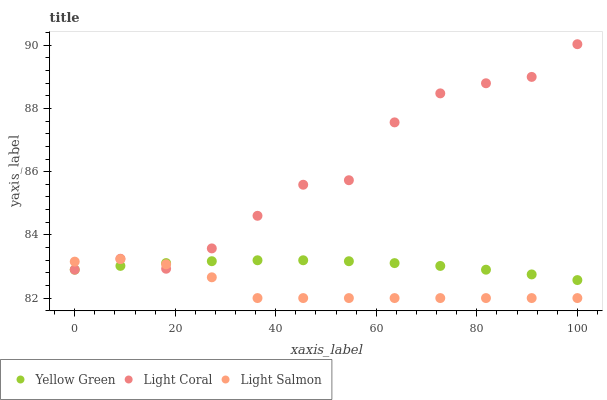Does Light Salmon have the minimum area under the curve?
Answer yes or no. Yes. Does Light Coral have the maximum area under the curve?
Answer yes or no. Yes. Does Yellow Green have the minimum area under the curve?
Answer yes or no. No. Does Yellow Green have the maximum area under the curve?
Answer yes or no. No. Is Yellow Green the smoothest?
Answer yes or no. Yes. Is Light Coral the roughest?
Answer yes or no. Yes. Is Light Salmon the smoothest?
Answer yes or no. No. Is Light Salmon the roughest?
Answer yes or no. No. Does Light Salmon have the lowest value?
Answer yes or no. Yes. Does Yellow Green have the lowest value?
Answer yes or no. No. Does Light Coral have the highest value?
Answer yes or no. Yes. Does Light Salmon have the highest value?
Answer yes or no. No. Does Light Coral intersect Yellow Green?
Answer yes or no. Yes. Is Light Coral less than Yellow Green?
Answer yes or no. No. Is Light Coral greater than Yellow Green?
Answer yes or no. No. 